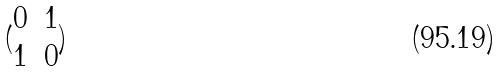Convert formula to latex. <formula><loc_0><loc_0><loc_500><loc_500>( \begin{matrix} 0 & 1 \\ 1 & 0 \end{matrix} )</formula> 